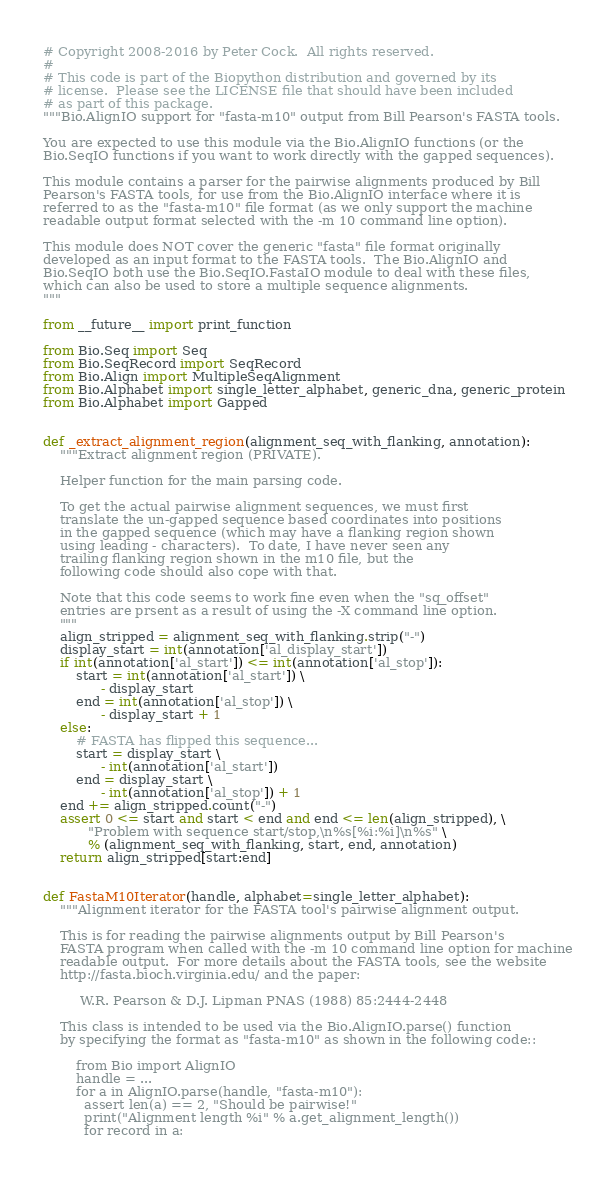Convert code to text. <code><loc_0><loc_0><loc_500><loc_500><_Python_># Copyright 2008-2016 by Peter Cock.  All rights reserved.
#
# This code is part of the Biopython distribution and governed by its
# license.  Please see the LICENSE file that should have been included
# as part of this package.
"""Bio.AlignIO support for "fasta-m10" output from Bill Pearson's FASTA tools.

You are expected to use this module via the Bio.AlignIO functions (or the
Bio.SeqIO functions if you want to work directly with the gapped sequences).

This module contains a parser for the pairwise alignments produced by Bill
Pearson's FASTA tools, for use from the Bio.AlignIO interface where it is
referred to as the "fasta-m10" file format (as we only support the machine
readable output format selected with the -m 10 command line option).

This module does NOT cover the generic "fasta" file format originally
developed as an input format to the FASTA tools.  The Bio.AlignIO and
Bio.SeqIO both use the Bio.SeqIO.FastaIO module to deal with these files,
which can also be used to store a multiple sequence alignments.
"""

from __future__ import print_function

from Bio.Seq import Seq
from Bio.SeqRecord import SeqRecord
from Bio.Align import MultipleSeqAlignment
from Bio.Alphabet import single_letter_alphabet, generic_dna, generic_protein
from Bio.Alphabet import Gapped


def _extract_alignment_region(alignment_seq_with_flanking, annotation):
    """Extract alignment region (PRIVATE).

    Helper function for the main parsing code.

    To get the actual pairwise alignment sequences, we must first
    translate the un-gapped sequence based coordinates into positions
    in the gapped sequence (which may have a flanking region shown
    using leading - characters).  To date, I have never seen any
    trailing flanking region shown in the m10 file, but the
    following code should also cope with that.

    Note that this code seems to work fine even when the "sq_offset"
    entries are prsent as a result of using the -X command line option.
    """
    align_stripped = alignment_seq_with_flanking.strip("-")
    display_start = int(annotation['al_display_start'])
    if int(annotation['al_start']) <= int(annotation['al_stop']):
        start = int(annotation['al_start']) \
              - display_start
        end = int(annotation['al_stop']) \
              - display_start + 1
    else:
        # FASTA has flipped this sequence...
        start = display_start \
              - int(annotation['al_start'])
        end = display_start \
              - int(annotation['al_stop']) + 1
    end += align_stripped.count("-")
    assert 0 <= start and start < end and end <= len(align_stripped), \
           "Problem with sequence start/stop,\n%s[%i:%i]\n%s" \
           % (alignment_seq_with_flanking, start, end, annotation)
    return align_stripped[start:end]


def FastaM10Iterator(handle, alphabet=single_letter_alphabet):
    """Alignment iterator for the FASTA tool's pairwise alignment output.

    This is for reading the pairwise alignments output by Bill Pearson's
    FASTA program when called with the -m 10 command line option for machine
    readable output.  For more details about the FASTA tools, see the website
    http://fasta.bioch.virginia.edu/ and the paper:

         W.R. Pearson & D.J. Lipman PNAS (1988) 85:2444-2448

    This class is intended to be used via the Bio.AlignIO.parse() function
    by specifying the format as "fasta-m10" as shown in the following code::

        from Bio import AlignIO
        handle = ...
        for a in AlignIO.parse(handle, "fasta-m10"):
          assert len(a) == 2, "Should be pairwise!"
          print("Alignment length %i" % a.get_alignment_length())
          for record in a:</code> 